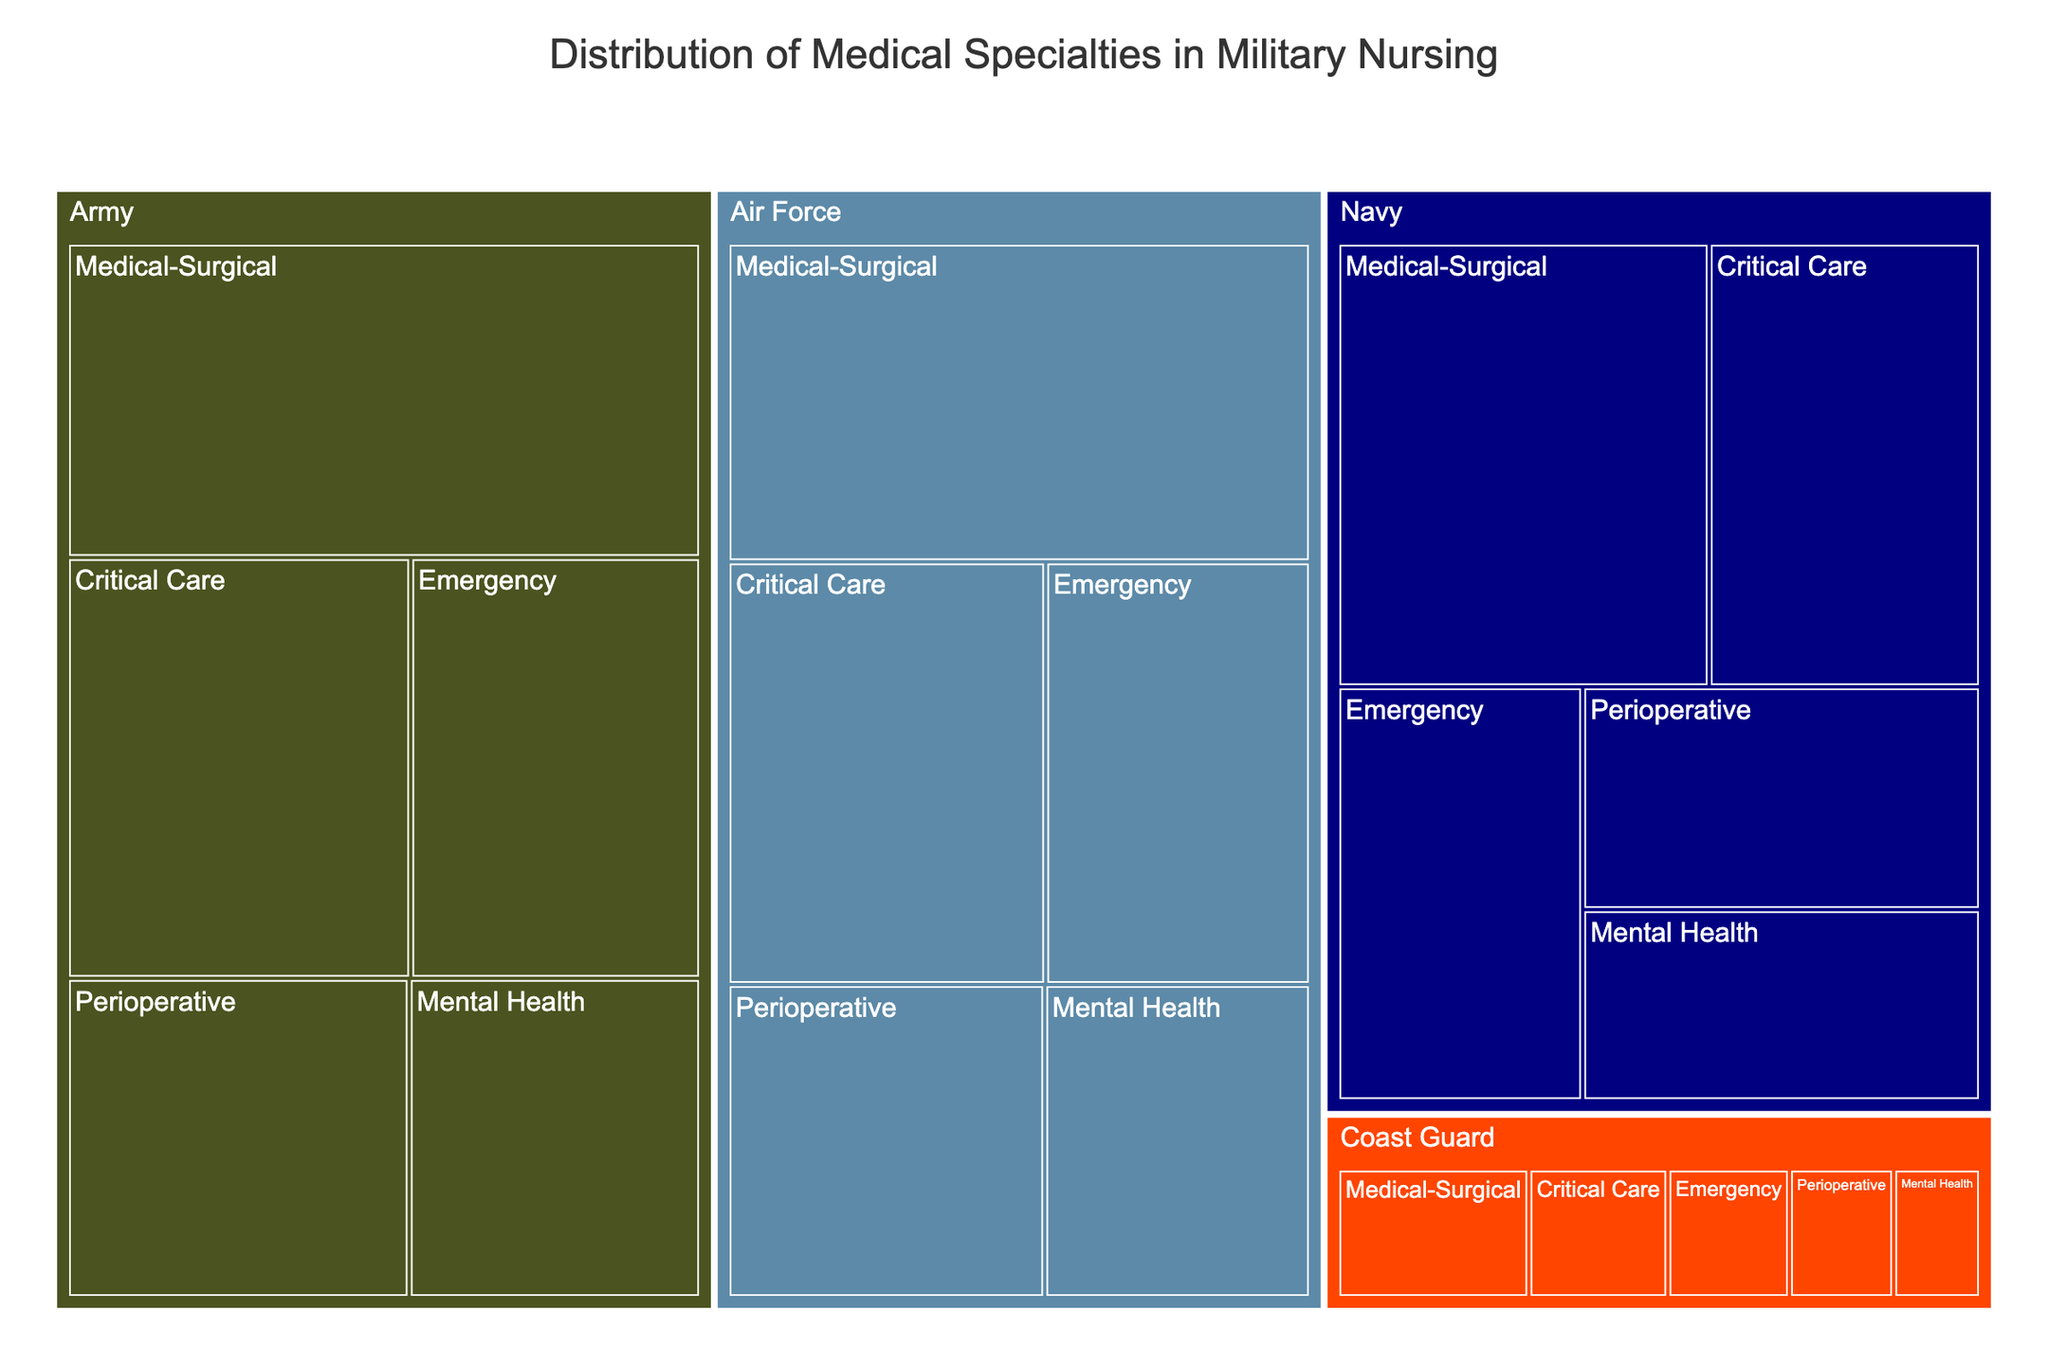What's the highest number of nurses within a single medical specialty for the Army? Refer to the section labeled “Army” and identify the medical specialty with the largest size box. The biggest box in the Army section is "Medical-Surgical" with a size indicating 620 nurses.
Answer: 620 Which service branch has the smallest number of nurses in Critical Care? Compare the size of the "Critical Care" boxes among all service branches (Army, Navy, Air Force, Coast Guard). The Coast Guard has the smallest box for Critical Care with 80 nurses.
Answer: Coast Guard What is the total number of nurses in the Air Force? Add the numbers of nurses in each specialty for the Air Force: Critical Care (420), Emergency (350), Medical-Surgical (580), Mental Health (260), and Perioperative (310). This sums up to 420 + 350 + 580 + 260 + 310 = 1920.
Answer: 1920 How does the number of Medical-Surgical nurses compare between the Navy and the Army? Locate the "Medical-Surgical" boxes in both the Navy and Army sections. The number of Medical-Surgical nurses in the Navy is 520, while in the Army, it is 620. The Army has 100 more nurses in this specialty than the Navy.
Answer: The Army has 100 more nurses Which specialty has the second most nurses in the Navy? In the Navy section, identify the second-largest box. The largest is Medical-Surgical (520), and the second largest is Critical Care (380), thus the second most populous specialty in Navy.
Answer: Critical Care What's the difference between the number of Mental Health nurses in the Army and the Air Force? Identify the number of Mental Health nurses in both (Army: 290, Air Force: 260). Subtract the smaller number from the larger: 290 - 260 = 30.
Answer: 30 How many specialties have more than 300 nurses in the Army? Check each box under the Army section and count those with more than 300 nurses. They are: Critical Care (450), Emergency (380), Medical-Surgical (620), and Perioperative (340), making a total of 4 specialties.
Answer: 4 Which service branch has the least total number of nurses? Sum up the number of nurses in each specialty for all service branches and compare the totals. The Coast Guard has the smallest boxes for all specialties and totals to 80 + 70 + 110 + 50 + 60 = 370.
Answer: Coast Guard Is there any specialty where all service branches have an equal number of nurses? Compare the counts for each specialty across all service branches. No specialty has the same number of nurses across all branches.
Answer: No 